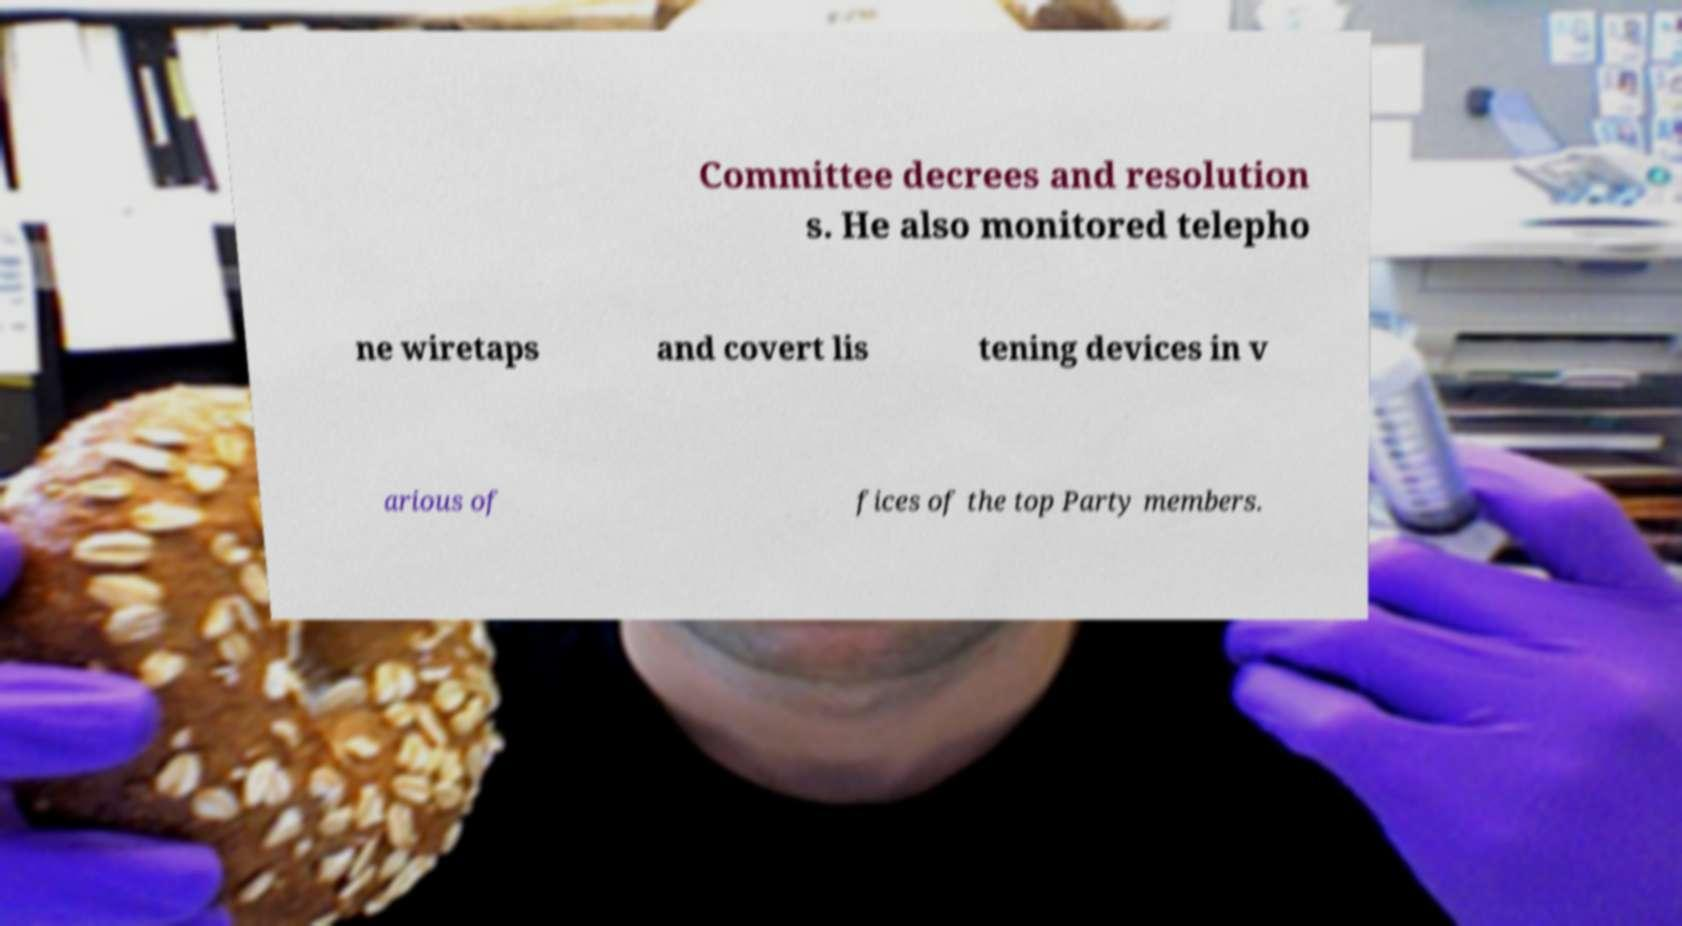There's text embedded in this image that I need extracted. Can you transcribe it verbatim? Committee decrees and resolution s. He also monitored telepho ne wiretaps and covert lis tening devices in v arious of fices of the top Party members. 